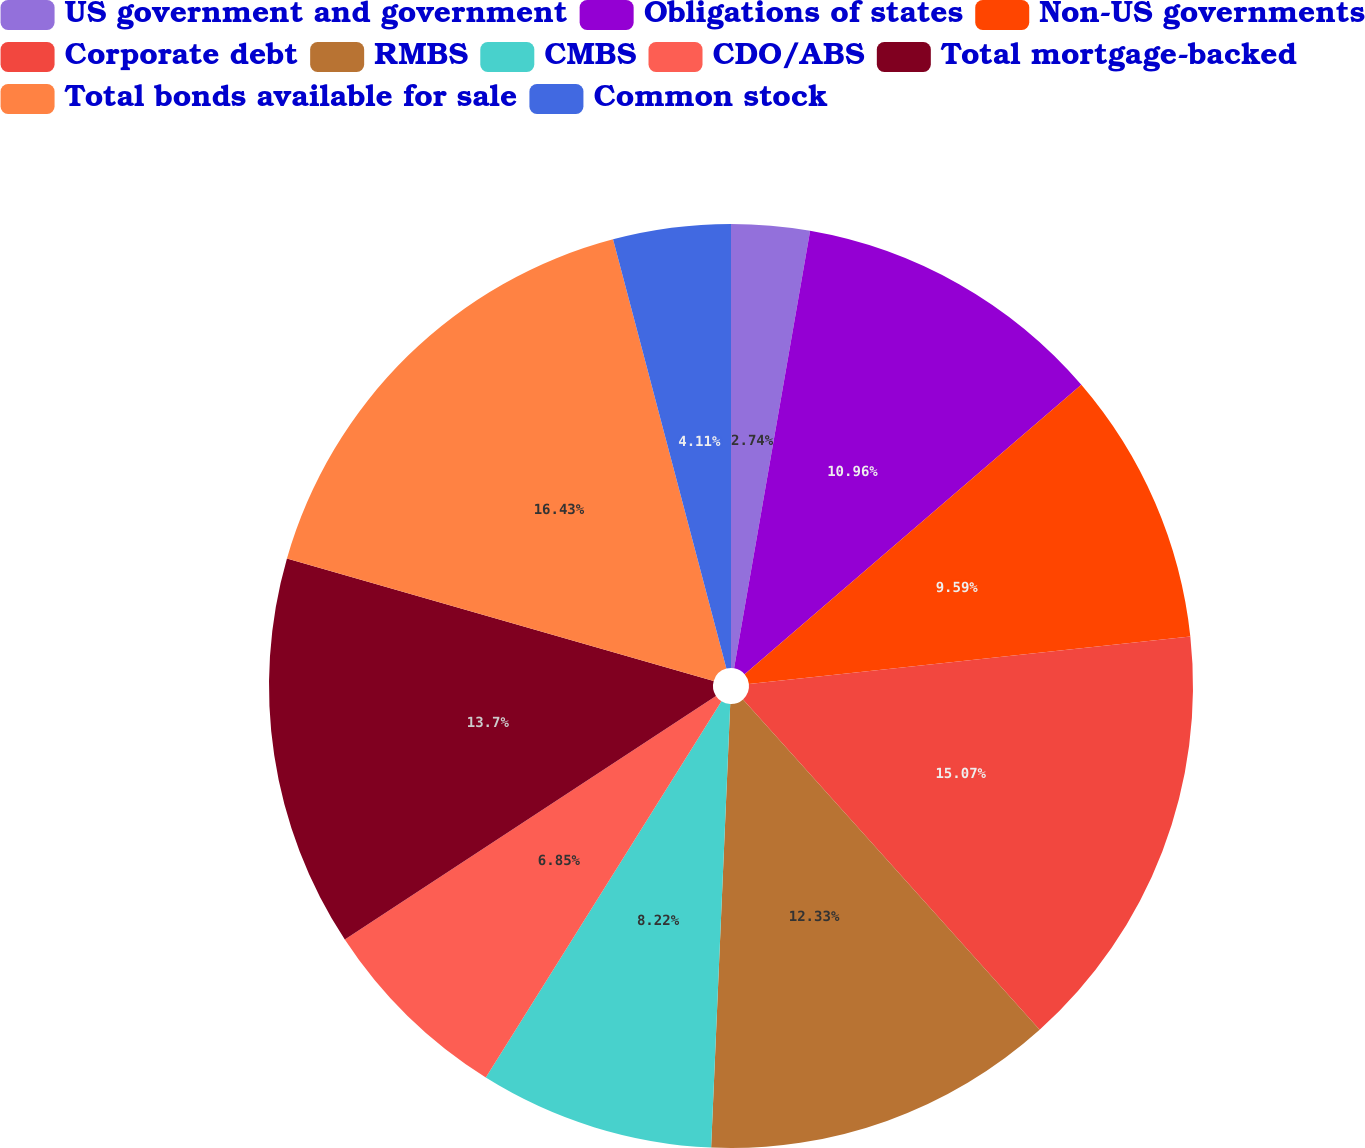Convert chart to OTSL. <chart><loc_0><loc_0><loc_500><loc_500><pie_chart><fcel>US government and government<fcel>Obligations of states<fcel>Non-US governments<fcel>Corporate debt<fcel>RMBS<fcel>CMBS<fcel>CDO/ABS<fcel>Total mortgage-backed<fcel>Total bonds available for sale<fcel>Common stock<nl><fcel>2.74%<fcel>10.96%<fcel>9.59%<fcel>15.07%<fcel>12.33%<fcel>8.22%<fcel>6.85%<fcel>13.7%<fcel>16.44%<fcel>4.11%<nl></chart> 